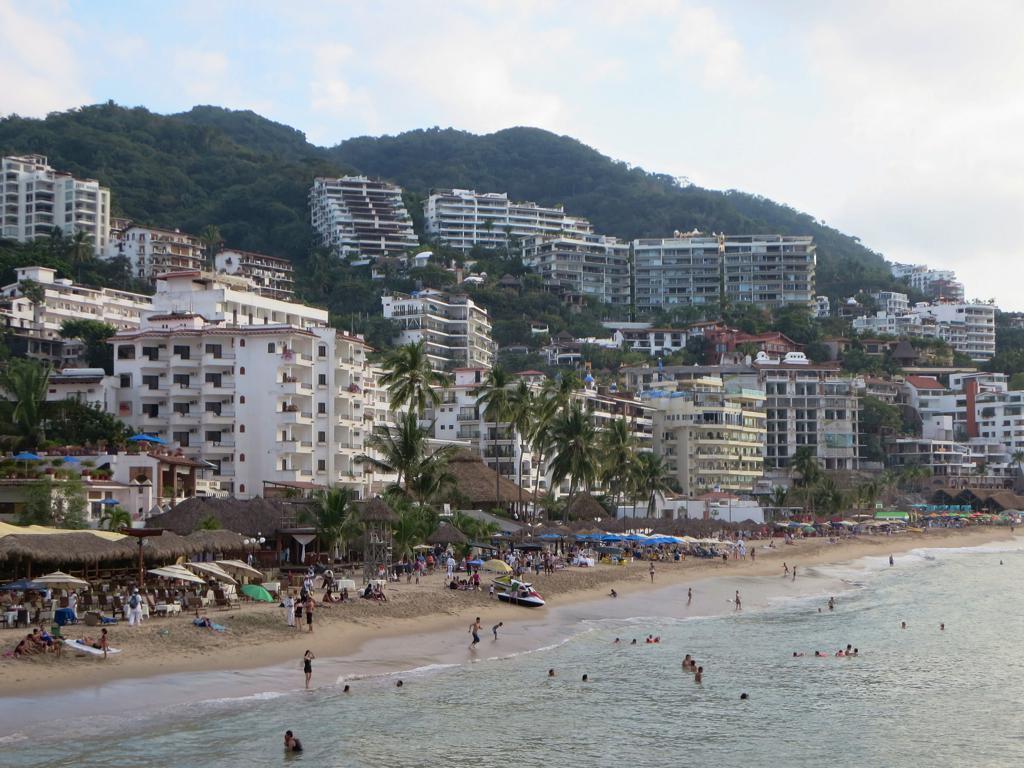In one or two sentences, can you explain what this image depicts? In this picture I can see the trees, mountains and buildings. At the bottom I can see some persons who are swimming in the water. In the center I can see many persons on the beach. Beside them I can see the tables, umbrellas, sheds and other objects. At the top I can see the sky and clouds. 